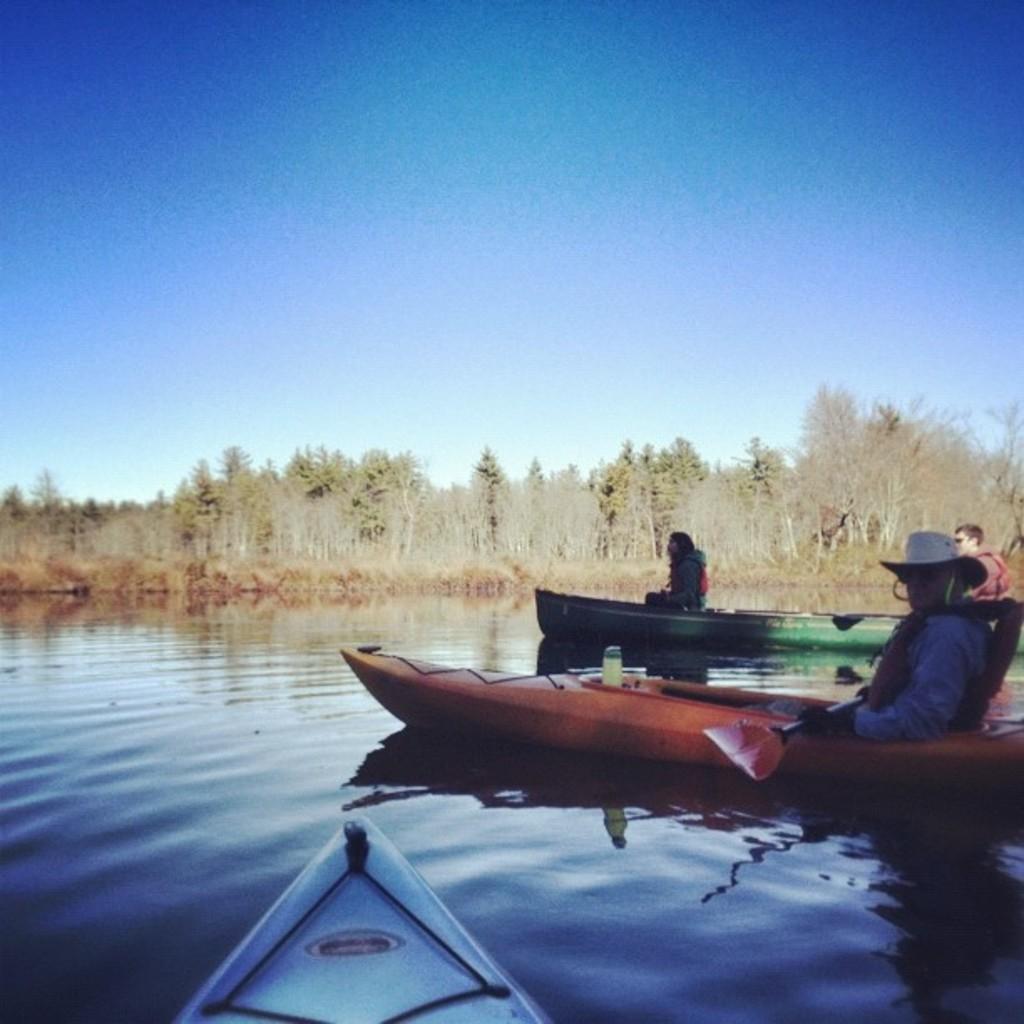How would you summarize this image in a sentence or two? In this image I can see few people are sitting in the boats. I can see few trees, sky and few boats on the water surface. 